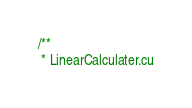Convert code to text. <code><loc_0><loc_0><loc_500><loc_500><_Cuda_>/**
 * LinearCalculater.cu</code> 